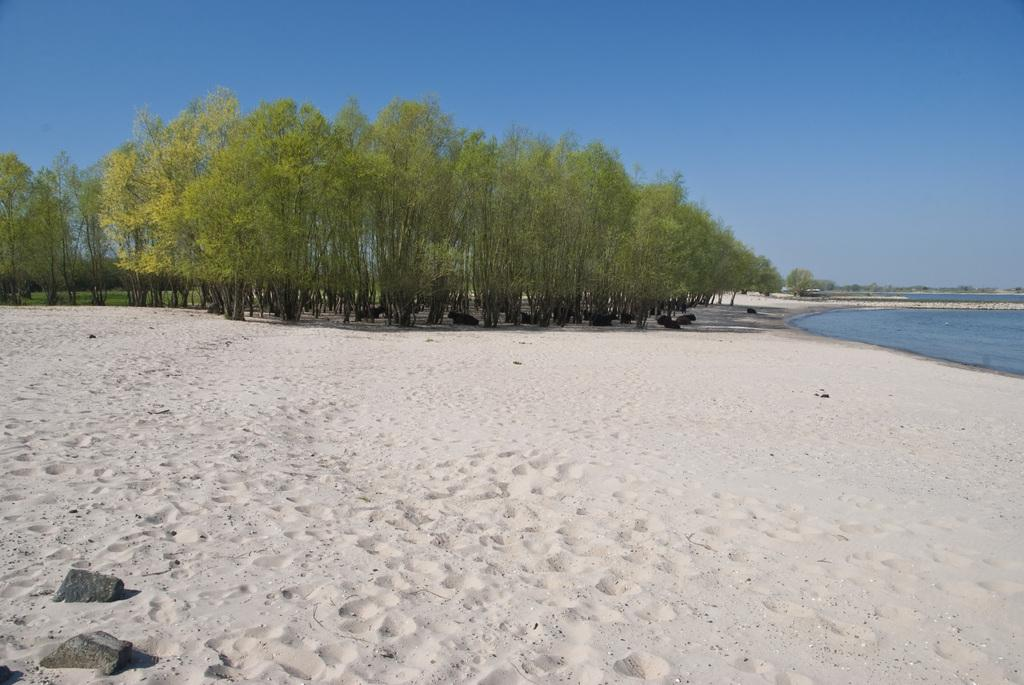What type of vegetation is present on the ground in the image? There are trees on the ground in the image. What can be seen on the right side of the image? There is water visible on the right side of the image. What is visible in the background of the image? The sky is visible in the background of the image. How many visitors are present in the image? There is no mention of visitors in the image, so it cannot be determined how many are present. Can you describe the kitten playing with the slip in the image? There is no kitten or slip present in the image. 